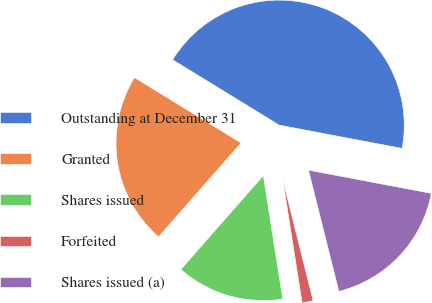<chart> <loc_0><loc_0><loc_500><loc_500><pie_chart><fcel>Outstanding at December 31<fcel>Granted<fcel>Shares issued<fcel>Forfeited<fcel>Shares issued (a)<nl><fcel>44.22%<fcel>22.28%<fcel>13.95%<fcel>1.43%<fcel>18.11%<nl></chart> 